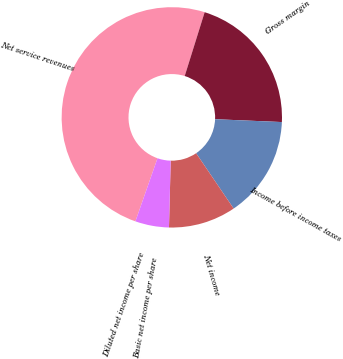<chart> <loc_0><loc_0><loc_500><loc_500><pie_chart><fcel>Net service revenues<fcel>Gross margin<fcel>Income before income taxes<fcel>Net income<fcel>Basic net income per share<fcel>Diluted net income per share<nl><fcel>49.46%<fcel>20.86%<fcel>14.84%<fcel>9.89%<fcel>4.95%<fcel>0.0%<nl></chart> 